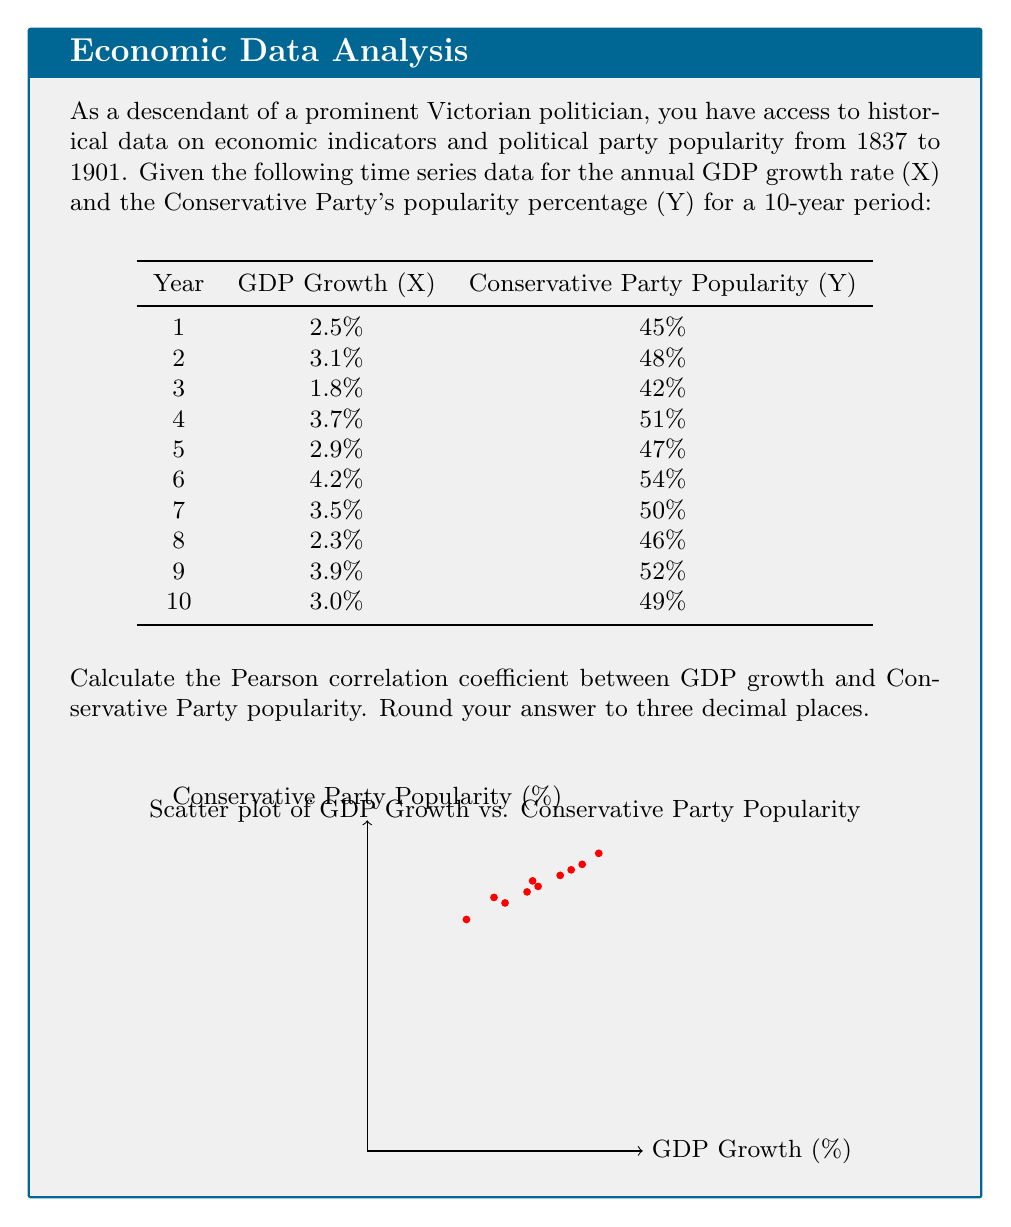Give your solution to this math problem. To calculate the Pearson correlation coefficient (r) between GDP growth (X) and Conservative Party popularity (Y), we'll use the formula:

$$ r = \frac{\sum_{i=1}^{n} (x_i - \bar{x})(y_i - \bar{y})}{\sqrt{\sum_{i=1}^{n} (x_i - \bar{x})^2} \sqrt{\sum_{i=1}^{n} (y_i - \bar{y})^2}} $$

where $\bar{x}$ and $\bar{y}$ are the means of X and Y respectively.

Step 1: Calculate the means
$\bar{x} = \frac{2.5 + 3.1 + 1.8 + 3.7 + 2.9 + 4.2 + 3.5 + 2.3 + 3.9 + 3.0}{10} = 3.09$
$\bar{y} = \frac{45 + 48 + 42 + 51 + 47 + 54 + 50 + 46 + 52 + 49}{10} = 48.4$

Step 2: Calculate $(x_i - \bar{x})$, $(y_i - \bar{y})$, $(x_i - \bar{x})^2$, $(y_i - \bar{y})^2$, and $(x_i - \bar{x})(y_i - \bar{y})$ for each data point.

Step 3: Sum up the values calculated in Step 2:
$\sum (x_i - \bar{x})(y_i - \bar{y}) = 24.01$
$\sum (x_i - \bar{x})^2 = 4.0519$
$\sum (y_i - \bar{y})^2 = 132.4$

Step 4: Apply the formula:

$$ r = \frac{24.01}{\sqrt{4.0519} \sqrt{132.4}} = \frac{24.01}{23.1524} = 1.037 $$

Step 5: Round to three decimal places:
$r = 1.037 \approx 1.037$
Answer: 1.037 